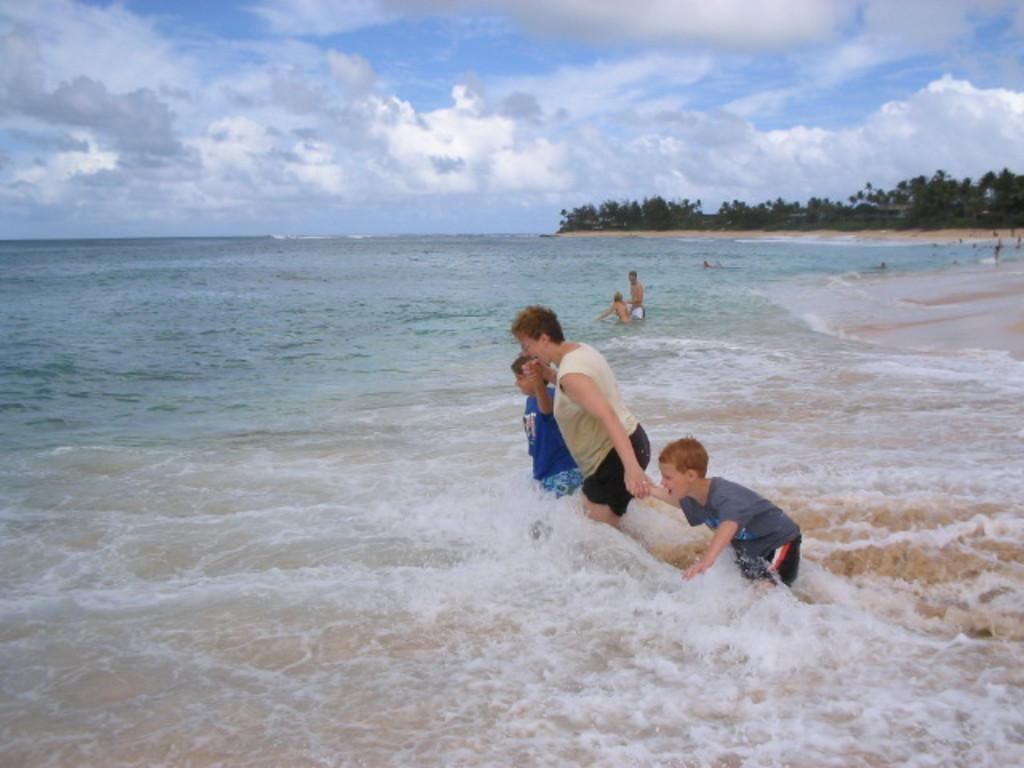Can you describe this image briefly? In this picture we can see water at the bottom, there are some people in the middle, we can see trees in the background, there is the sky and clouds at the top of the picture. 